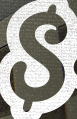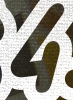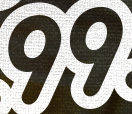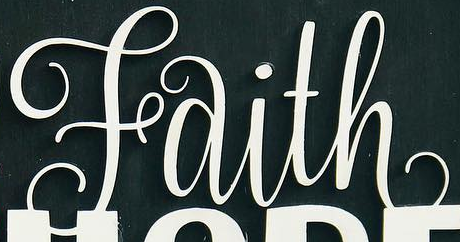Identify the words shown in these images in order, separated by a semicolon. $; 4; 99; Faith 